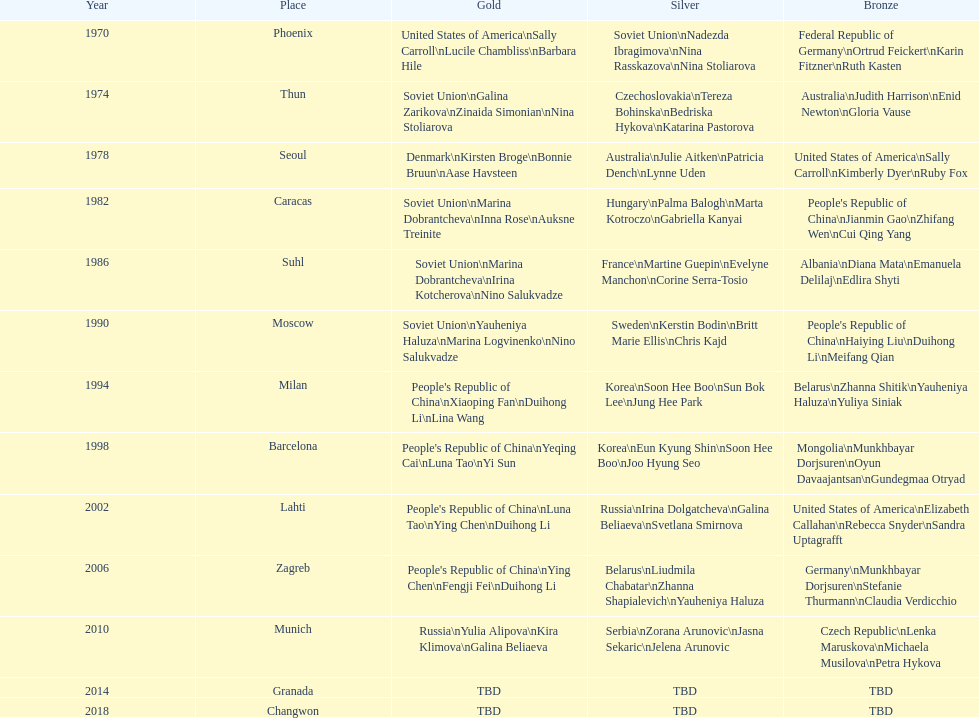Name one of the top three women to earn gold at the 1970 world championship held in phoenix, az Sally Carroll. 